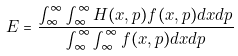Convert formula to latex. <formula><loc_0><loc_0><loc_500><loc_500>E = \frac { \int _ { \infty } ^ { \infty } \int _ { \infty } ^ { \infty } H ( x , p ) f ( x , p ) d x d p } { \int _ { \infty } ^ { \infty } \int _ { \infty } ^ { \infty } f ( x , p ) d x d p }</formula> 